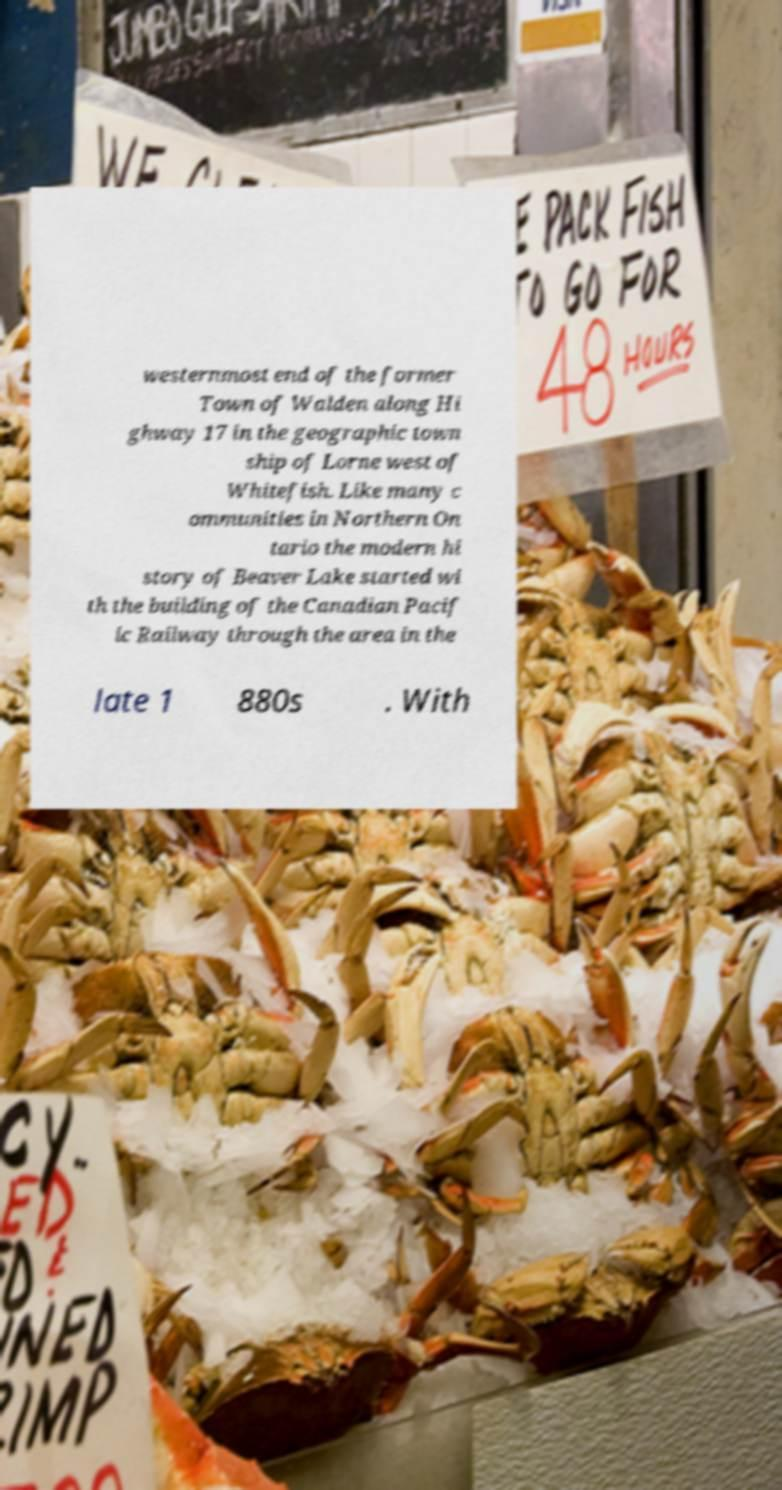Please identify and transcribe the text found in this image. westernmost end of the former Town of Walden along Hi ghway 17 in the geographic town ship of Lorne west of Whitefish. Like many c ommunities in Northern On tario the modern hi story of Beaver Lake started wi th the building of the Canadian Pacif ic Railway through the area in the late 1 880s . With 